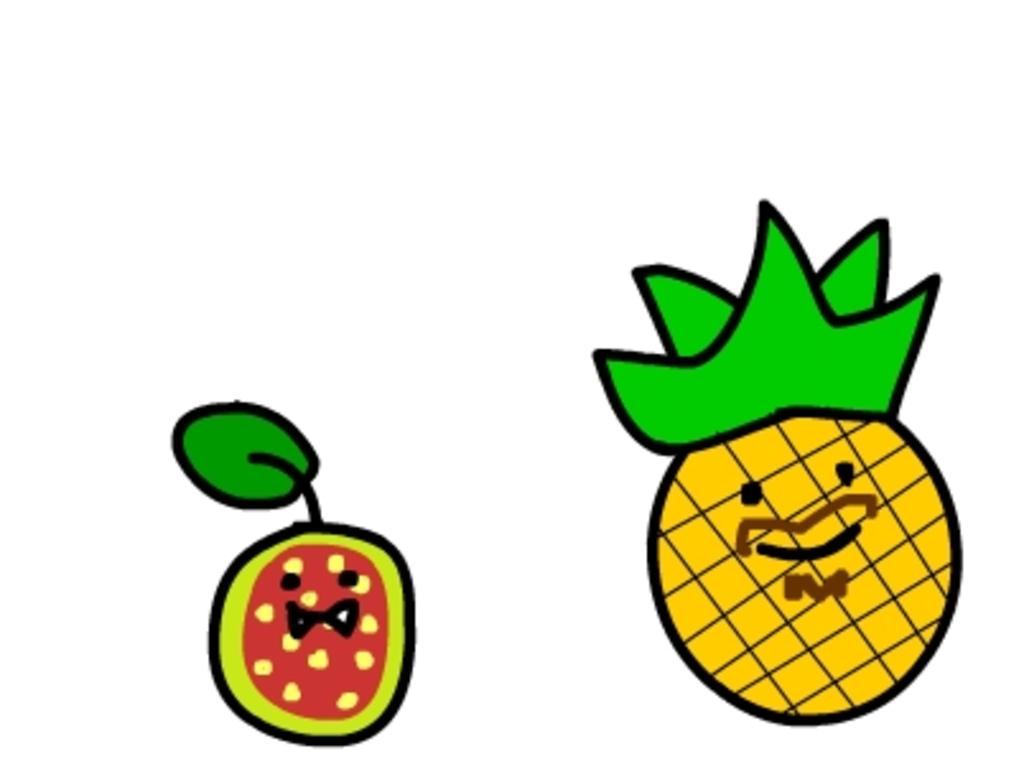Please provide a concise description of this image. In this image there is a painting of two fruits having leaves. Background is white in color. 